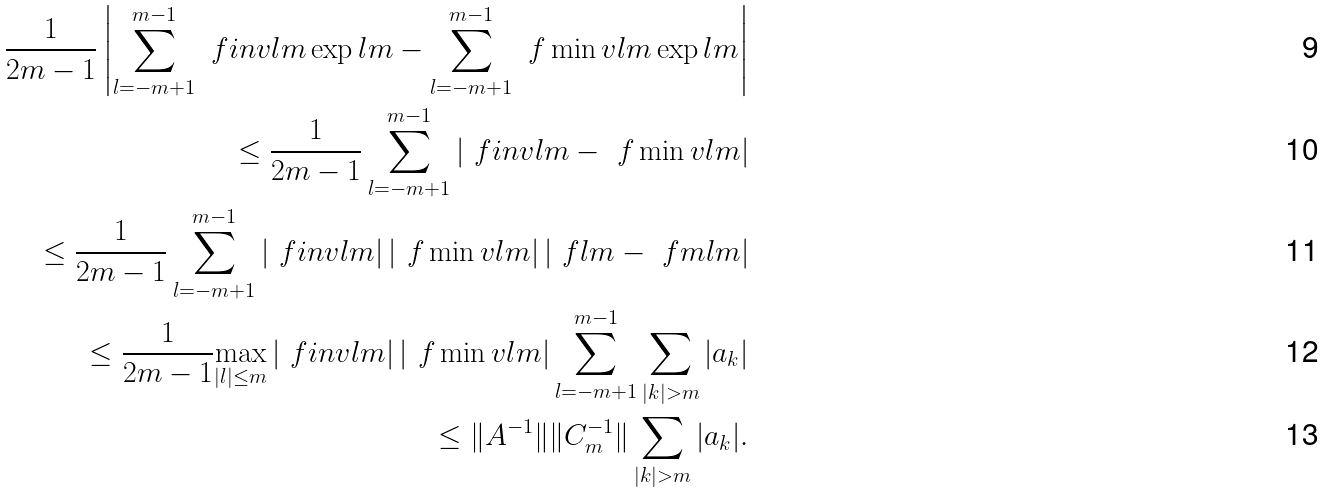Convert formula to latex. <formula><loc_0><loc_0><loc_500><loc_500>\frac { 1 } { 2 m - 1 } \left | \sum _ { l = - m + 1 } ^ { m - 1 } \ f i n v l m \exp l m - \sum _ { l = - m + 1 } ^ { m - 1 } \ f \min v l m \exp l m \right | \\ \leq \frac { 1 } { 2 m - 1 } \sum _ { l = - m + 1 } ^ { m - 1 } \left | \ f i n v l m - \ f \min v l m \right | \\ \leq \frac { 1 } { 2 m - 1 } \sum _ { l = - m + 1 } ^ { m - 1 } \left | \ f i n v l m \right | \left | \ f \min v l m \right | \left | \ f l m - \ f m l m \right | \\ \leq \frac { 1 } { 2 m - 1 } \underset { | l | \leq m } { \max } \left | \ f i n v l m \right | \left | \ f \min v l m \right | \sum _ { l = - m + 1 } ^ { m - 1 } \sum _ { | k | > m } | a _ { k } | \\ \leq \| A ^ { - 1 } \| \| C _ { m } ^ { - 1 } \| \sum _ { | k | > m } | a _ { k } | .</formula> 